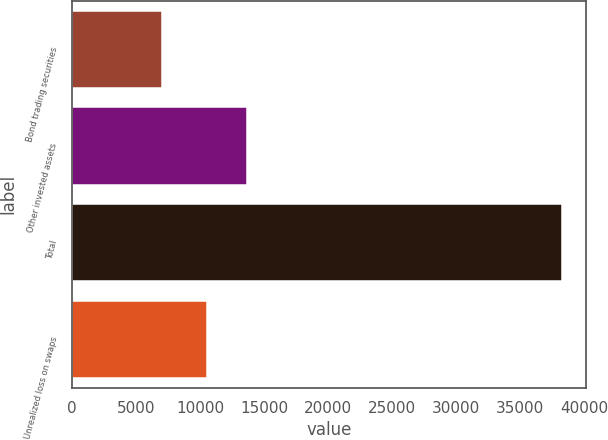<chart> <loc_0><loc_0><loc_500><loc_500><bar_chart><fcel>Bond trading securities<fcel>Other invested assets<fcel>Total<fcel>Unrealized loss on swaps<nl><fcel>6987<fcel>13696.3<fcel>38250<fcel>10570<nl></chart> 